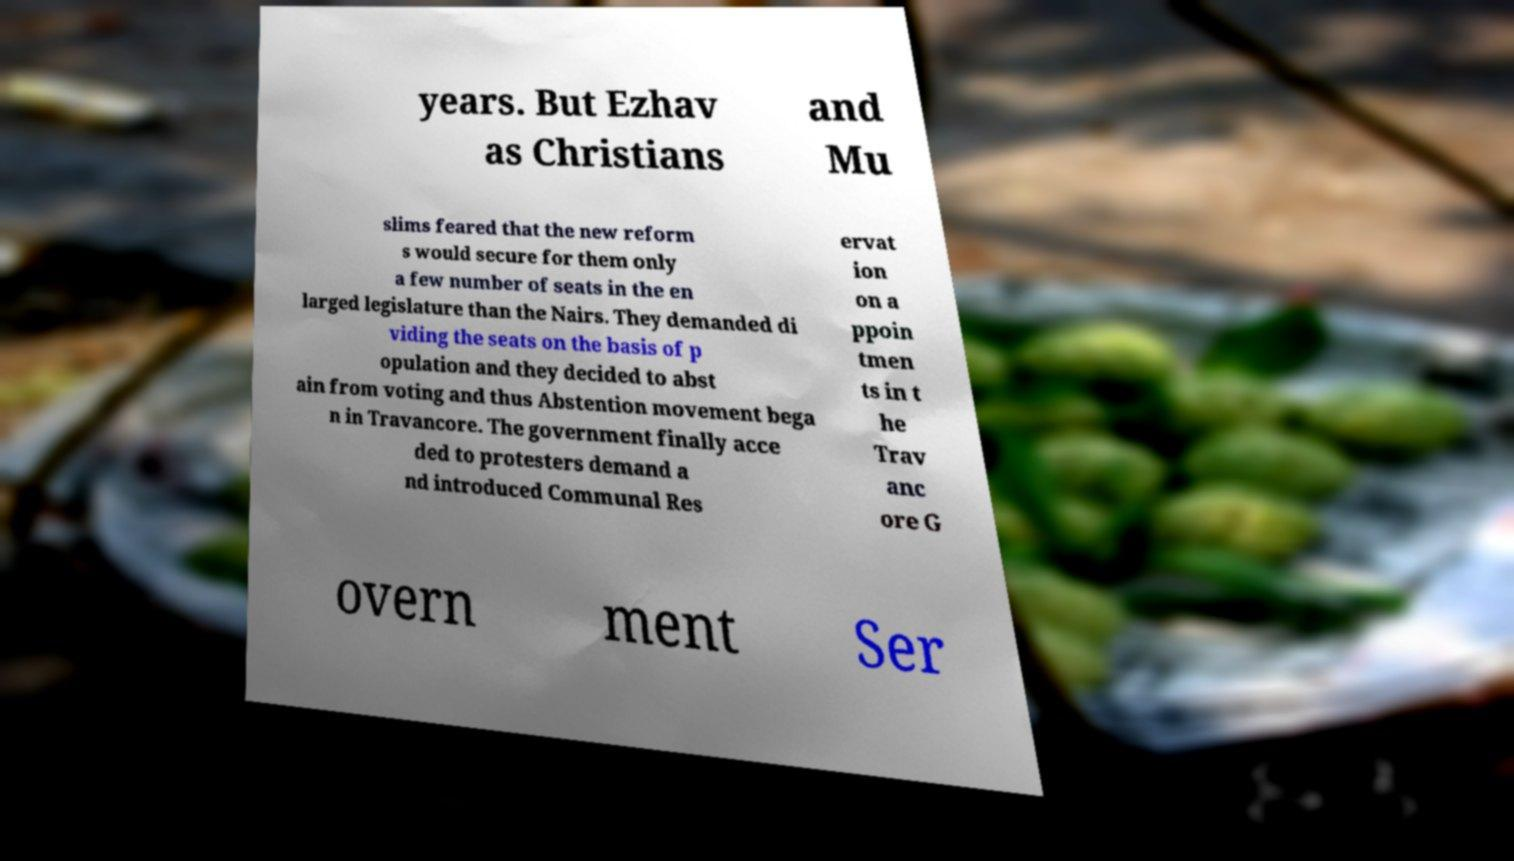Please read and relay the text visible in this image. What does it say? years. But Ezhav as Christians and Mu slims feared that the new reform s would secure for them only a few number of seats in the en larged legislature than the Nairs. They demanded di viding the seats on the basis of p opulation and they decided to abst ain from voting and thus Abstention movement bega n in Travancore. The government finally acce ded to protesters demand a nd introduced Communal Res ervat ion on a ppoin tmen ts in t he Trav anc ore G overn ment Ser 